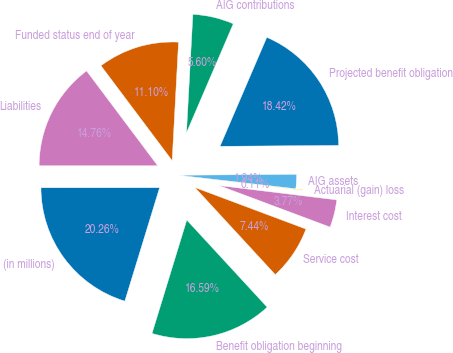Convert chart to OTSL. <chart><loc_0><loc_0><loc_500><loc_500><pie_chart><fcel>(in millions)<fcel>Benefit obligation beginning<fcel>Service cost<fcel>Interest cost<fcel>Actuarial (gain) loss<fcel>AIG assets<fcel>Projected benefit obligation<fcel>AIG contributions<fcel>Funded status end of year<fcel>Liabilities<nl><fcel>20.26%<fcel>16.59%<fcel>7.44%<fcel>3.77%<fcel>0.11%<fcel>1.94%<fcel>18.42%<fcel>5.6%<fcel>11.1%<fcel>14.76%<nl></chart> 